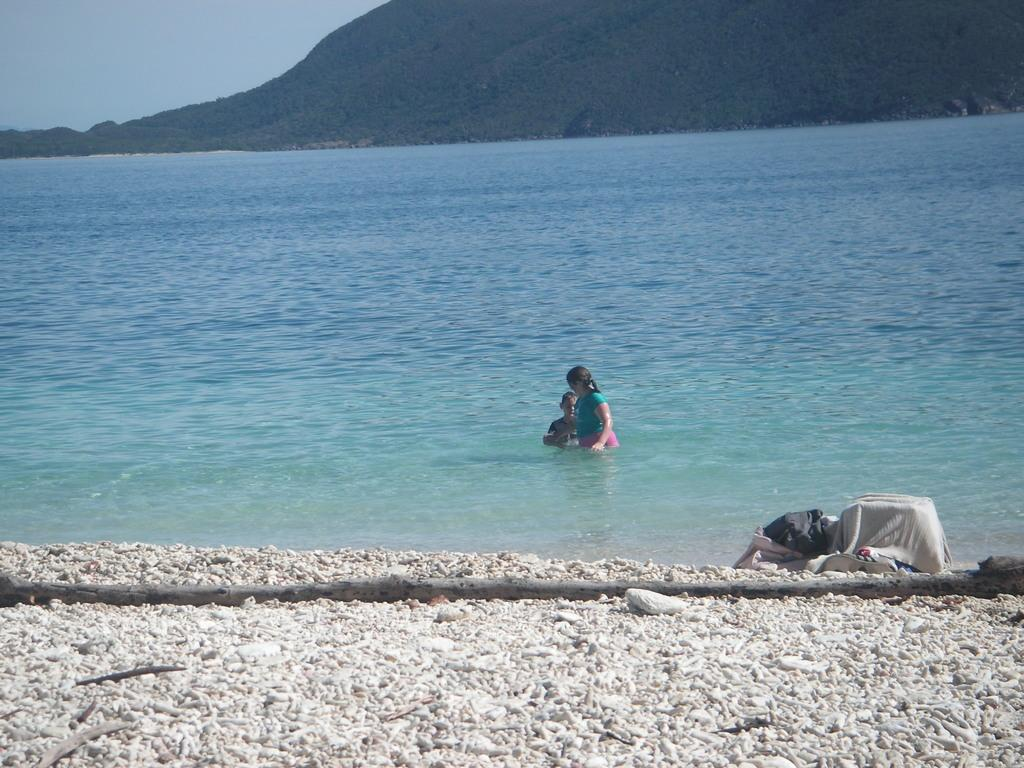What are the people in the image doing? The people in the image are in the water. What type of terrain can be seen in the image? There is sand visible in the image. What part of the natural environment is visible in the image? The sky is visible in the image. Can you find the receipt for the beach umbrella in the image? There is no receipt present in the image. What type of wind can be seen in the image? There is no wind visible in the image, and the term "zephyr" is not relevant to the image. 